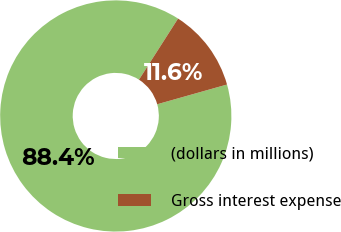Convert chart to OTSL. <chart><loc_0><loc_0><loc_500><loc_500><pie_chart><fcel>(dollars in millions)<fcel>Gross interest expense<nl><fcel>88.44%<fcel>11.56%<nl></chart> 